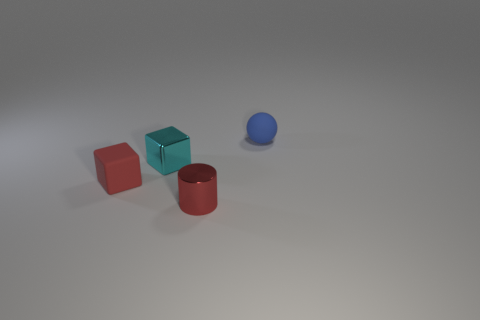What number of blue matte balls are the same size as the cyan object?
Give a very brief answer. 1. Are there the same number of red objects in front of the tiny red metal cylinder and blue matte things in front of the blue matte thing?
Ensure brevity in your answer.  Yes. Does the red cube have the same material as the small cyan block?
Your answer should be compact. No. There is a small matte object in front of the tiny blue rubber sphere; is there a shiny object that is left of it?
Your response must be concise. No. Are there any other cyan things that have the same shape as the small cyan metal object?
Ensure brevity in your answer.  No. Is the color of the small matte ball the same as the metallic cube?
Offer a terse response. No. What is the material of the tiny cube that is behind the rubber thing that is left of the red metal cylinder?
Provide a short and direct response. Metal. The blue matte thing has what size?
Your answer should be very brief. Small. There is a red thing that is made of the same material as the small ball; what size is it?
Give a very brief answer. Small. There is a cube in front of the cyan block; does it have the same size as the cyan cube?
Your response must be concise. Yes. 